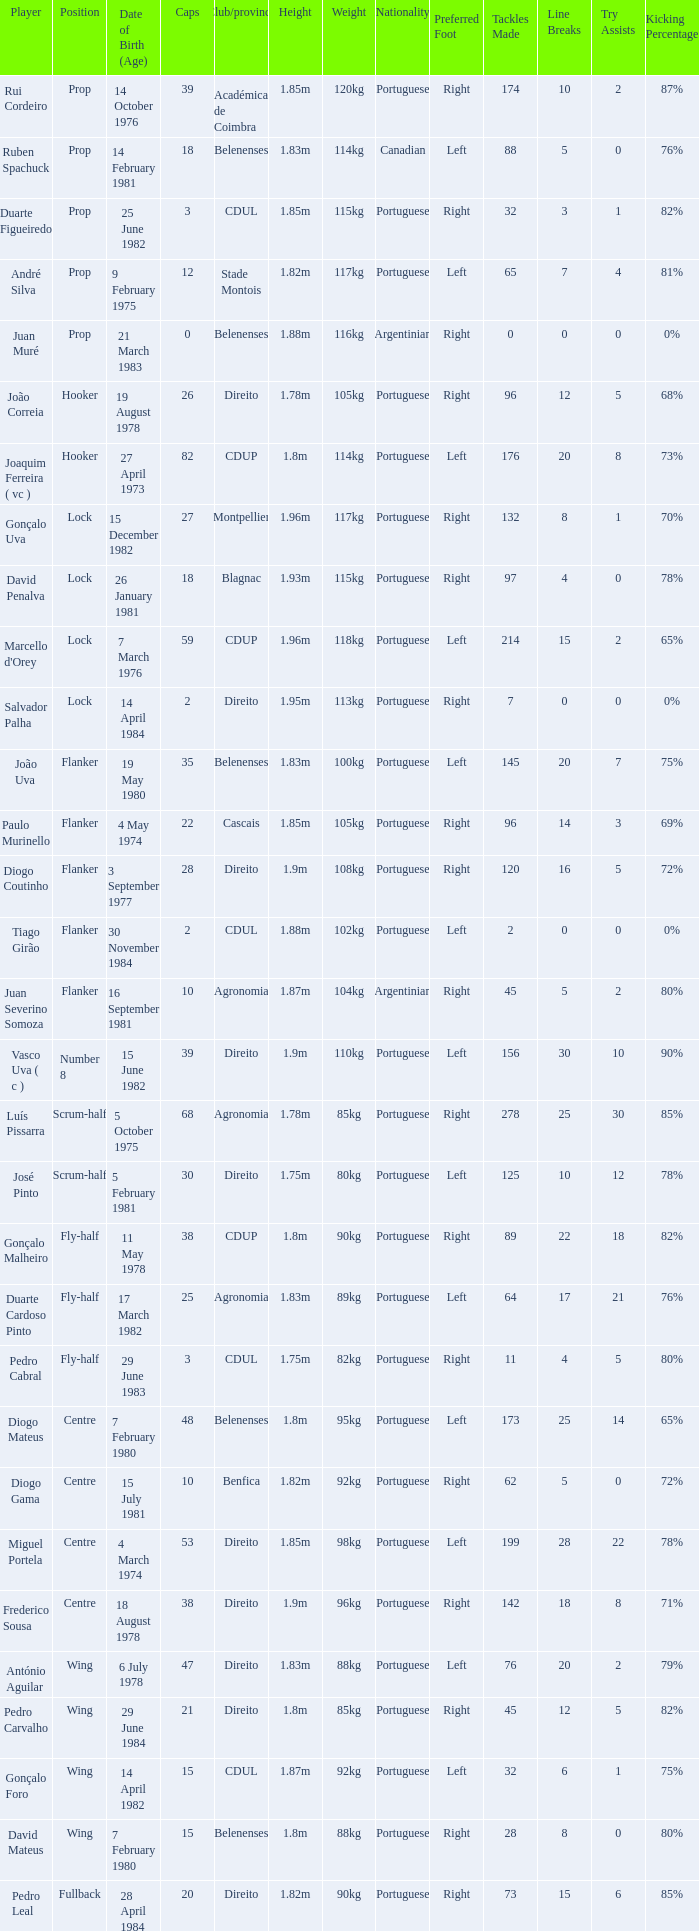How many caps have a Date of Birth (Age) of 15 july 1981? 1.0. 